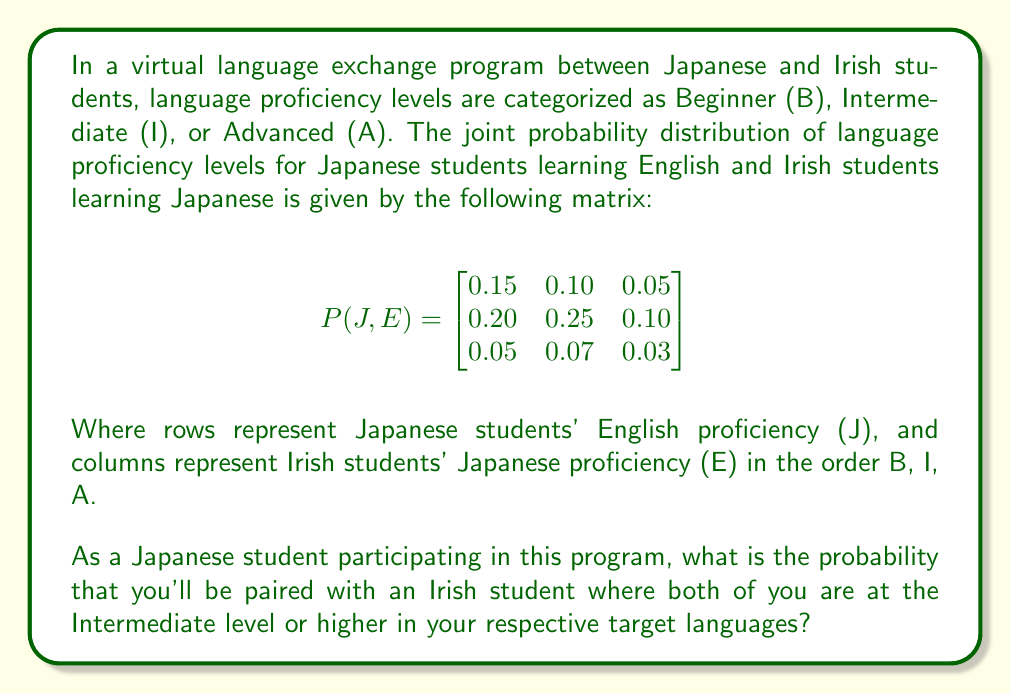Provide a solution to this math problem. To solve this problem, we need to follow these steps:

1) Identify the probabilities we need to sum:
   - P(J=I, E=I), P(J=I, E=A), P(J=A, E=I), P(J=A, E=A)

2) Locate these probabilities in the given matrix:
   - P(J=I, E=I) = 0.25
   - P(J=I, E=A) = 0.10
   - P(J=A, E=I) = 0.07
   - P(J=A, E=A) = 0.03

3) Sum these probabilities:

   $$P(\text{Both Intermediate or higher}) = 0.25 + 0.10 + 0.07 + 0.03$$

4) Calculate the final result:

   $$P(\text{Both Intermediate or higher}) = 0.45$$

Therefore, the probability of being paired with an Irish student where both students are at the Intermediate level or higher is 0.45 or 45%.
Answer: 0.45 